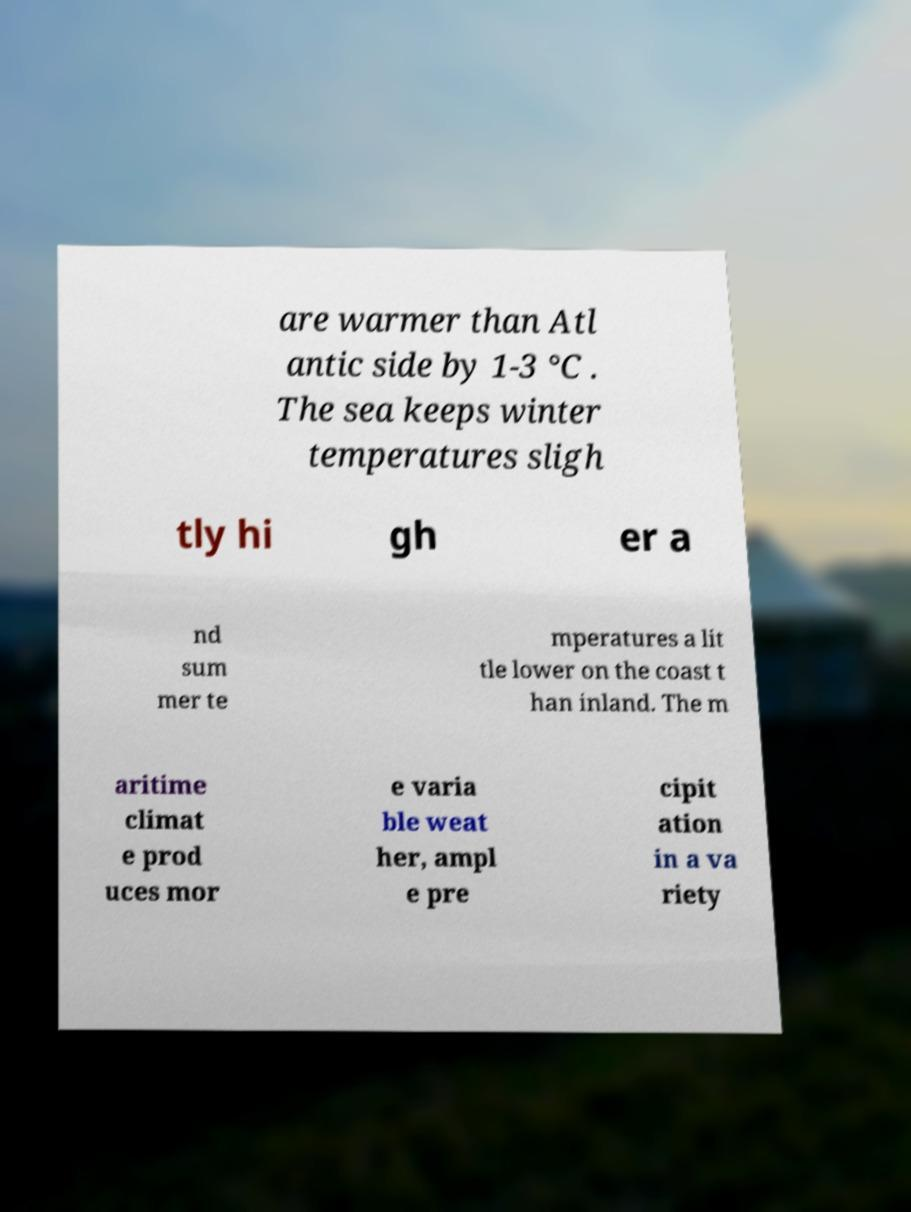Could you assist in decoding the text presented in this image and type it out clearly? are warmer than Atl antic side by 1-3 °C . The sea keeps winter temperatures sligh tly hi gh er a nd sum mer te mperatures a lit tle lower on the coast t han inland. The m aritime climat e prod uces mor e varia ble weat her, ampl e pre cipit ation in a va riety 